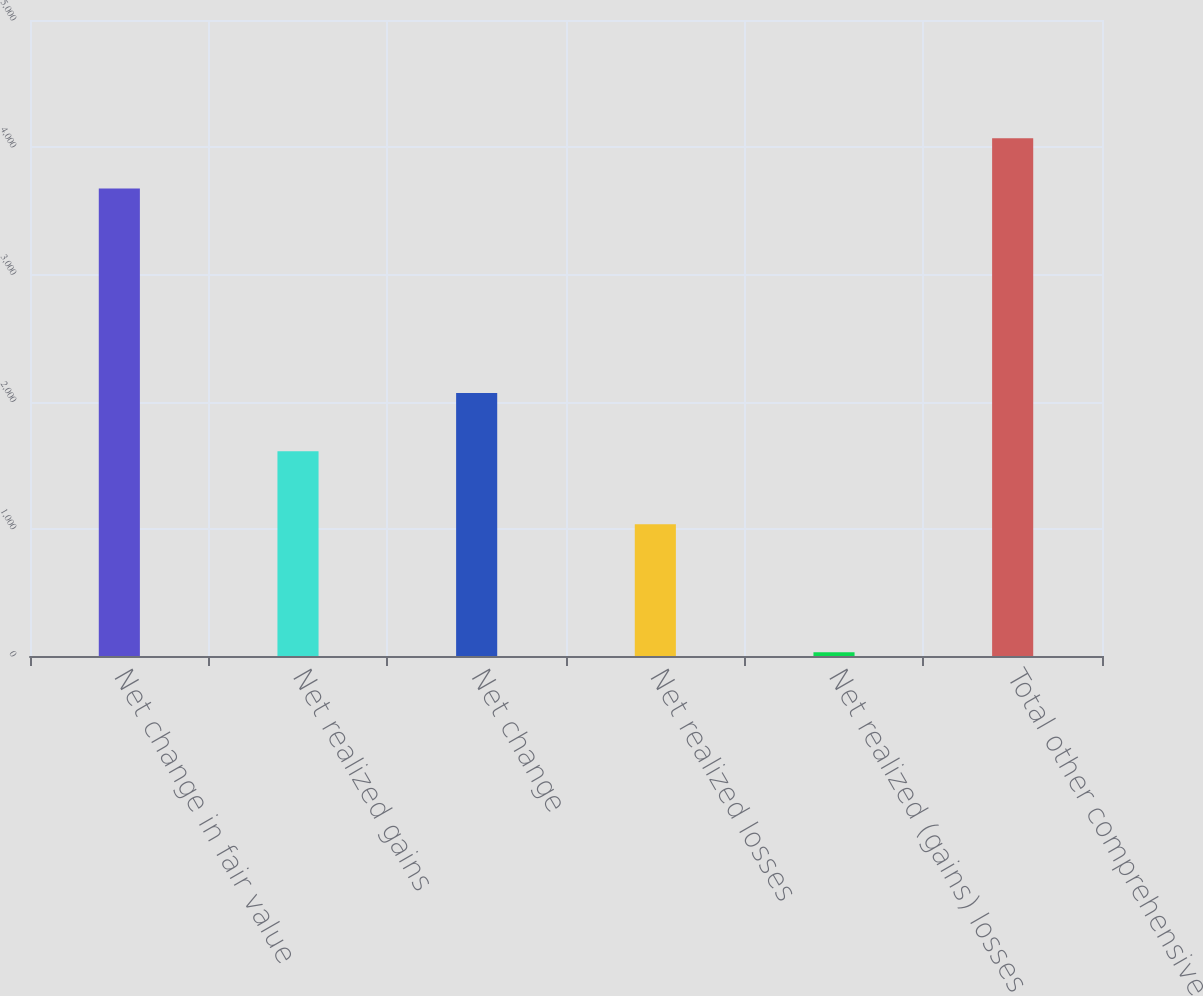Convert chart. <chart><loc_0><loc_0><loc_500><loc_500><bar_chart><fcel>Net change in fair value<fcel>Net realized gains<fcel>Net change<fcel>Net realized losses<fcel>Net realized (gains) losses<fcel>Total other comprehensive<nl><fcel>3676<fcel>1609<fcel>2067<fcel>1035<fcel>30<fcel>4071.2<nl></chart> 